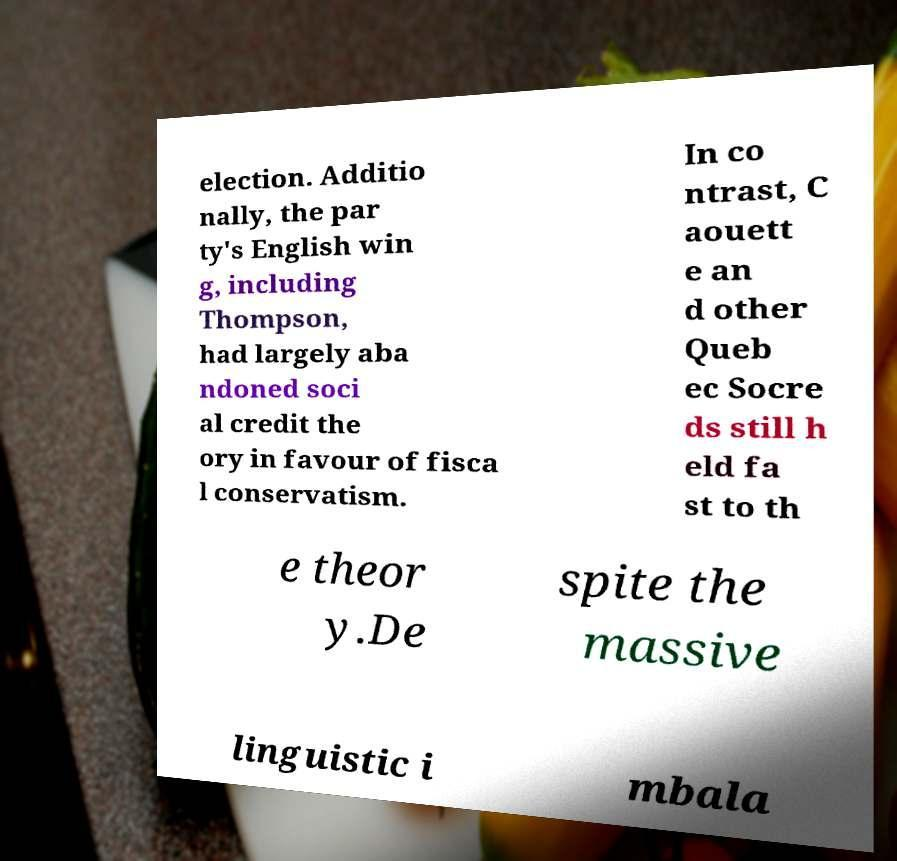What messages or text are displayed in this image? I need them in a readable, typed format. election. Additio nally, the par ty's English win g, including Thompson, had largely aba ndoned soci al credit the ory in favour of fisca l conservatism. In co ntrast, C aouett e an d other Queb ec Socre ds still h eld fa st to th e theor y.De spite the massive linguistic i mbala 